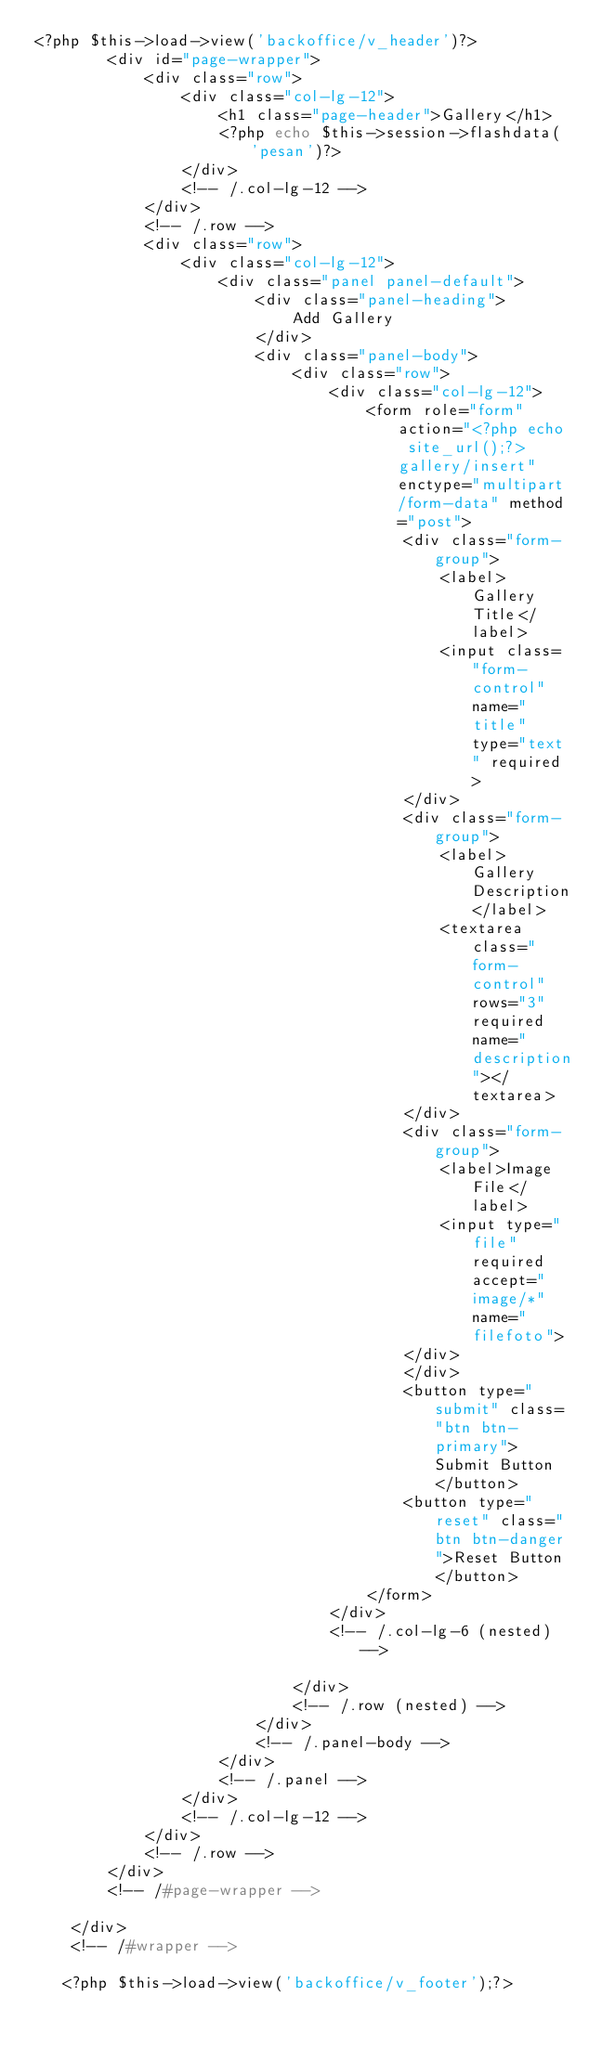Convert code to text. <code><loc_0><loc_0><loc_500><loc_500><_PHP_><?php $this->load->view('backoffice/v_header')?>
        <div id="page-wrapper">
            <div class="row">
                <div class="col-lg-12">
                    <h1 class="page-header">Gallery</h1>
                    <?php echo $this->session->flashdata('pesan')?>
                </div>
                <!-- /.col-lg-12 -->
            </div>
            <!-- /.row -->
            <div class="row">
                <div class="col-lg-12">
                    <div class="panel panel-default">
                        <div class="panel-heading">
                            Add Gallery
                        </div>
                        <div class="panel-body">
                            <div class="row">
                                <div class="col-lg-12">
                                    <form role="form" action="<?php echo site_url();?>gallery/insert" enctype="multipart/form-data" method="post">
                                        <div class="form-group">
                                            <label>Gallery Title</label>
                                            <input class="form-control" name="title" type="text" required>
                                        </div>
                                        <div class="form-group">
                                            <label>Gallery Description</label>
                                            <textarea class="form-control" rows="3" required name="description"></textarea>
                                        </div>
                                        <div class="form-group">
                                            <label>Image File</label>
                                            <input type="file" required accept="image/*" name="filefoto">
                                        </div>
                                        </div>
                                        <button type="submit" class="btn btn-primary">Submit Button</button>
                                        <button type="reset" class="btn btn-danger">Reset Button</button>
                                    </form>
                                </div>
                                <!-- /.col-lg-6 (nested) -->

                            </div>
                            <!-- /.row (nested) -->
                        </div>
                        <!-- /.panel-body -->
                    </div>
                    <!-- /.panel -->
                </div>
                <!-- /.col-lg-12 -->
            </div>
            <!-- /.row -->
        </div>
        <!-- /#page-wrapper -->

    </div>
    <!-- /#wrapper -->

   <?php $this->load->view('backoffice/v_footer');?></code> 